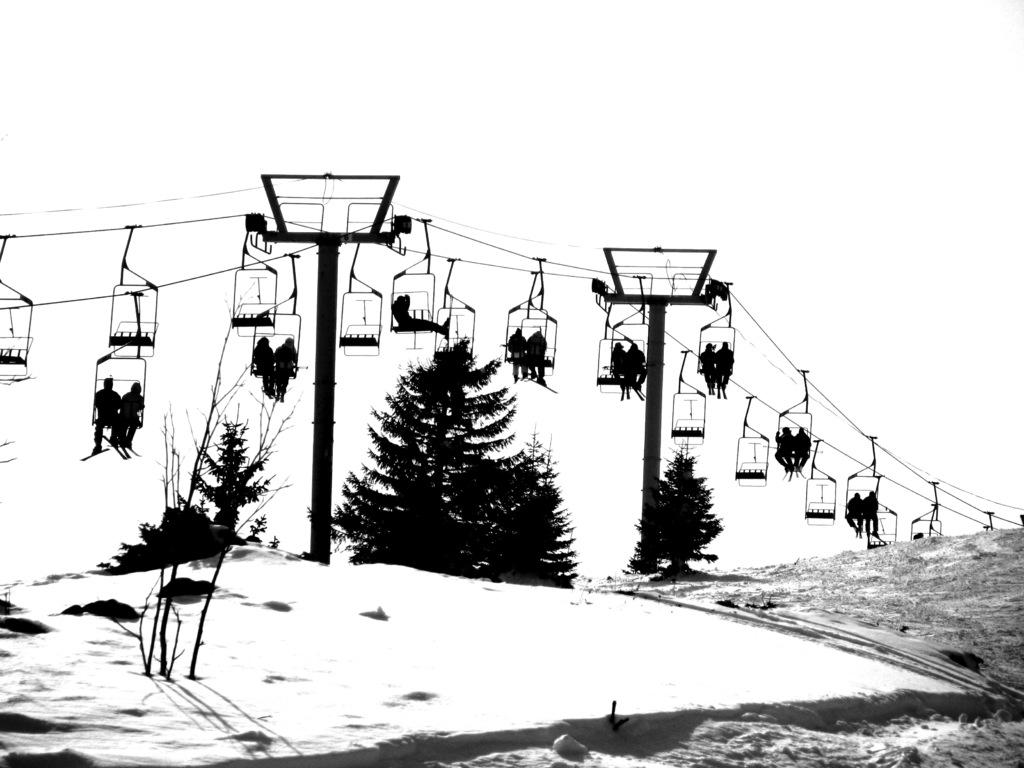What is present at the bottom of the image? There is snow at the bottom of the image. What can be seen in the image besides the snow? There are trees and a ropeway in the image. What is the ropeway connected to at the top of the image? The ropeway is connected to poles at the top of the image. Are there any people visible in the image? Yes, there are people in the ropeway. What type of breakfast is being served in the ropeway? There is no breakfast being served in the image; it features a ropeway with people in it. What is the thread used for in the image? There is no thread present in the image; it features a ropeway, snow, trees, and poles. 